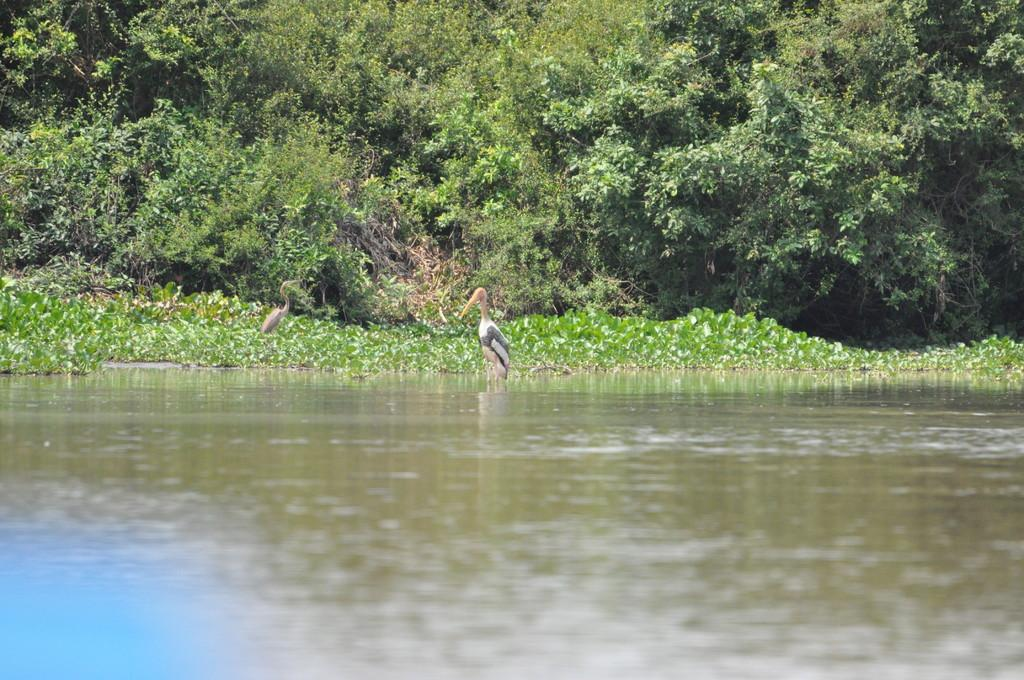What type of animals can be seen in the image? Birds can be seen in the water in the image. What else can be seen in the image besides the birds? Plants are visible in the image. Can you describe the vegetation in the image? There is a group of trees in the image. What type of note can be seen hanging from the tree in the image? There is no note hanging from any tree in the image; it only features birds in the water and plants. 